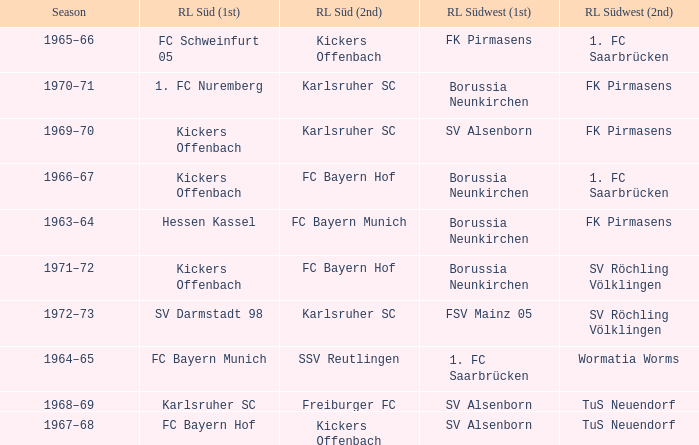What season was Freiburger FC the RL Süd (2nd) team? 1968–69. 